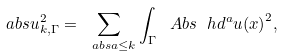<formula> <loc_0><loc_0><loc_500><loc_500>\ a b s { u } _ { k , \Gamma } ^ { 2 } = \sum _ { \ a b s { a } \leq k } \int _ { \Gamma } \ A b s { \ h d ^ { a } u ( x ) } ^ { 2 } ,</formula> 